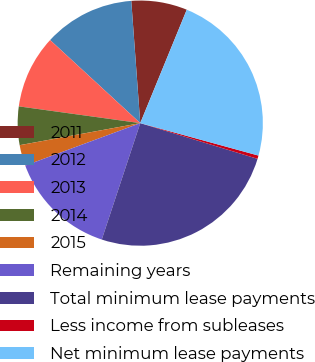Convert chart. <chart><loc_0><loc_0><loc_500><loc_500><pie_chart><fcel>2011<fcel>2012<fcel>2013<fcel>2014<fcel>2015<fcel>Remaining years<fcel>Total minimum lease payments<fcel>Less income from subleases<fcel>Net minimum lease payments<nl><fcel>7.36%<fcel>11.98%<fcel>9.67%<fcel>5.06%<fcel>2.75%<fcel>14.29%<fcel>25.38%<fcel>0.44%<fcel>23.07%<nl></chart> 